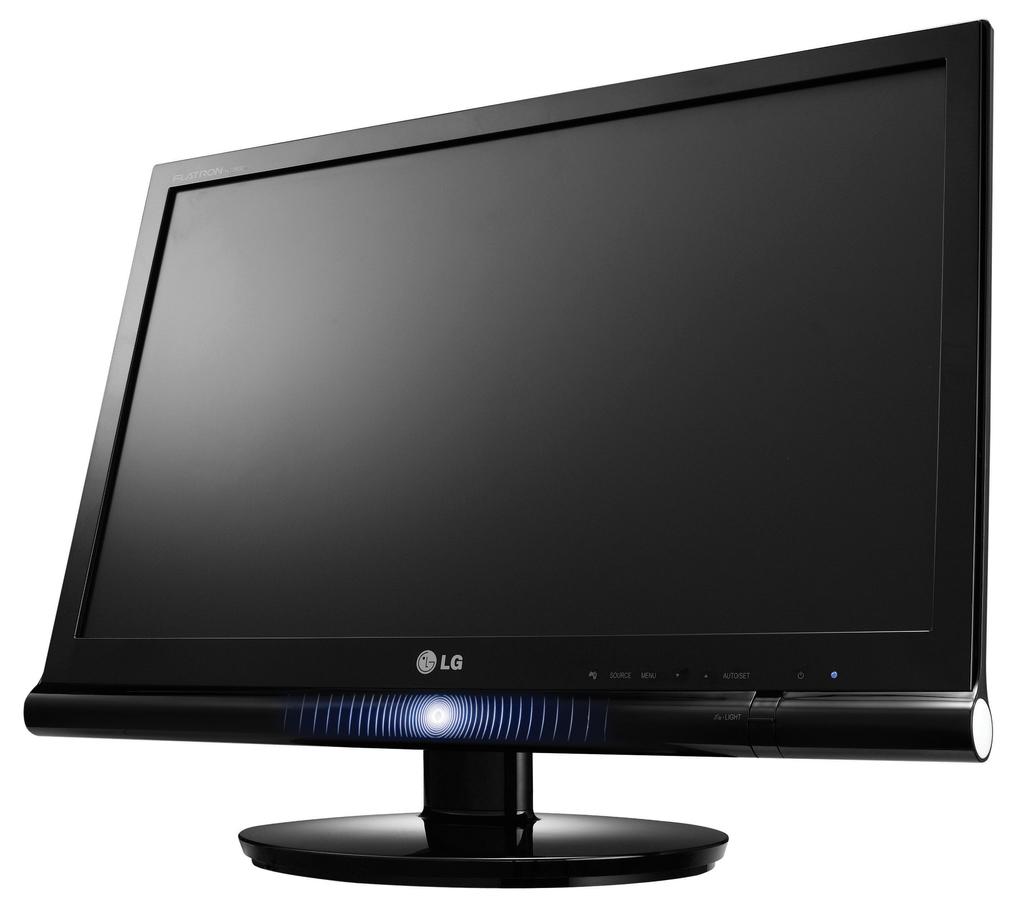What computer brand is this?
Your response must be concise. Lg. What is the first letter of the brand?
Your response must be concise. L. 